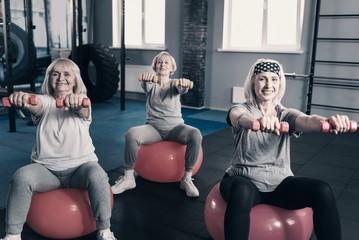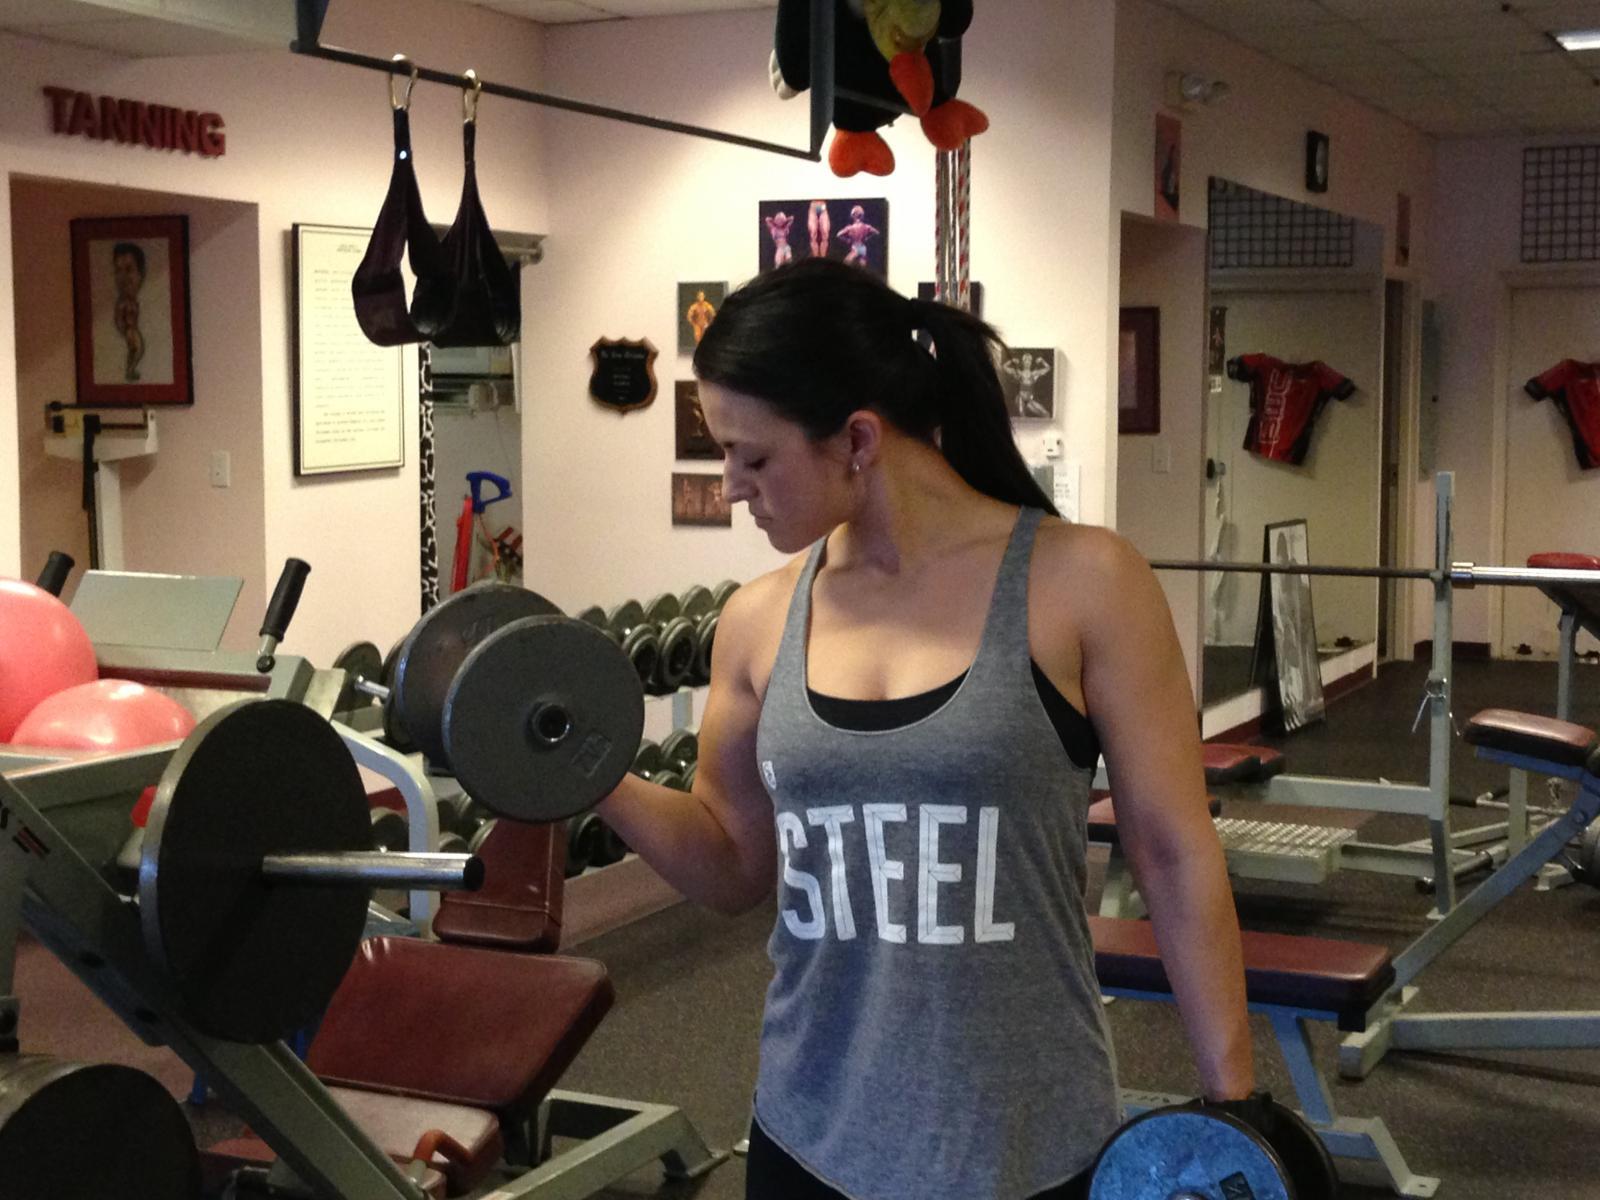The first image is the image on the left, the second image is the image on the right. Considering the images on both sides, is "Three women are sitting on exercise balls in one of the images." valid? Answer yes or no. Yes. The first image is the image on the left, the second image is the image on the right. Considering the images on both sides, is "An image shows three pale-haired women sitting on pink exercise balls." valid? Answer yes or no. Yes. 